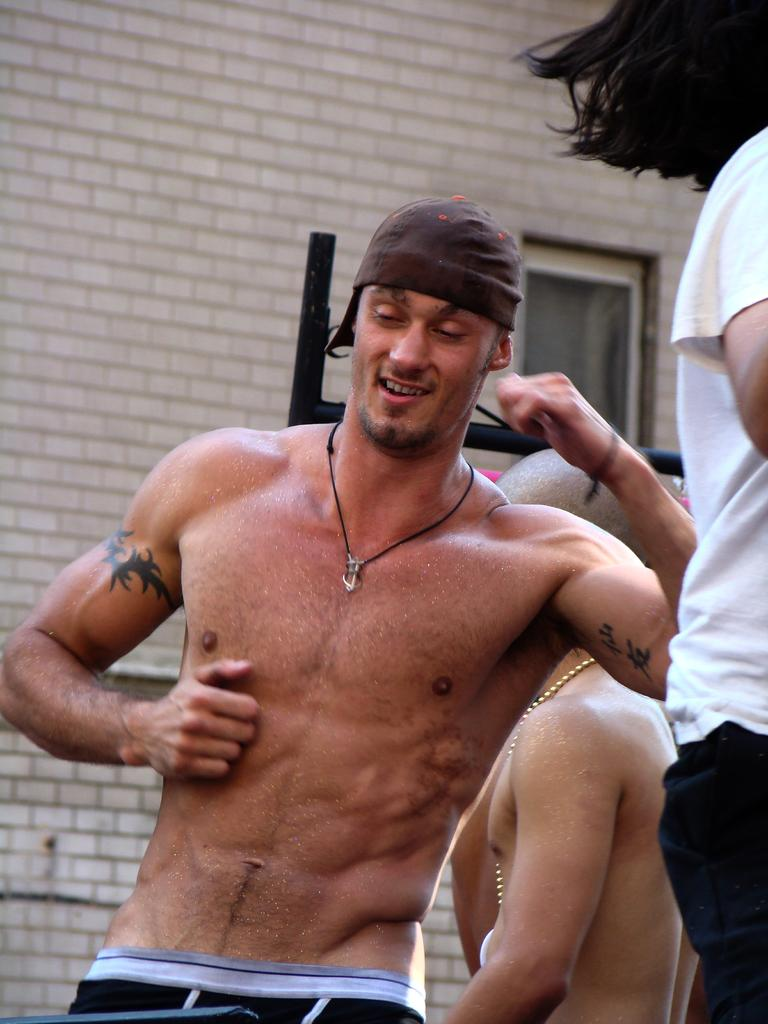What is happening in the image? There are people standing in the image. What can be seen in the background of the image? There are poles and a window on a wall in the background of the image. What type of cup is being used to make the statement in the image? There is no cup or statement present in the image; it only features people standing and poles and a window in the background. 